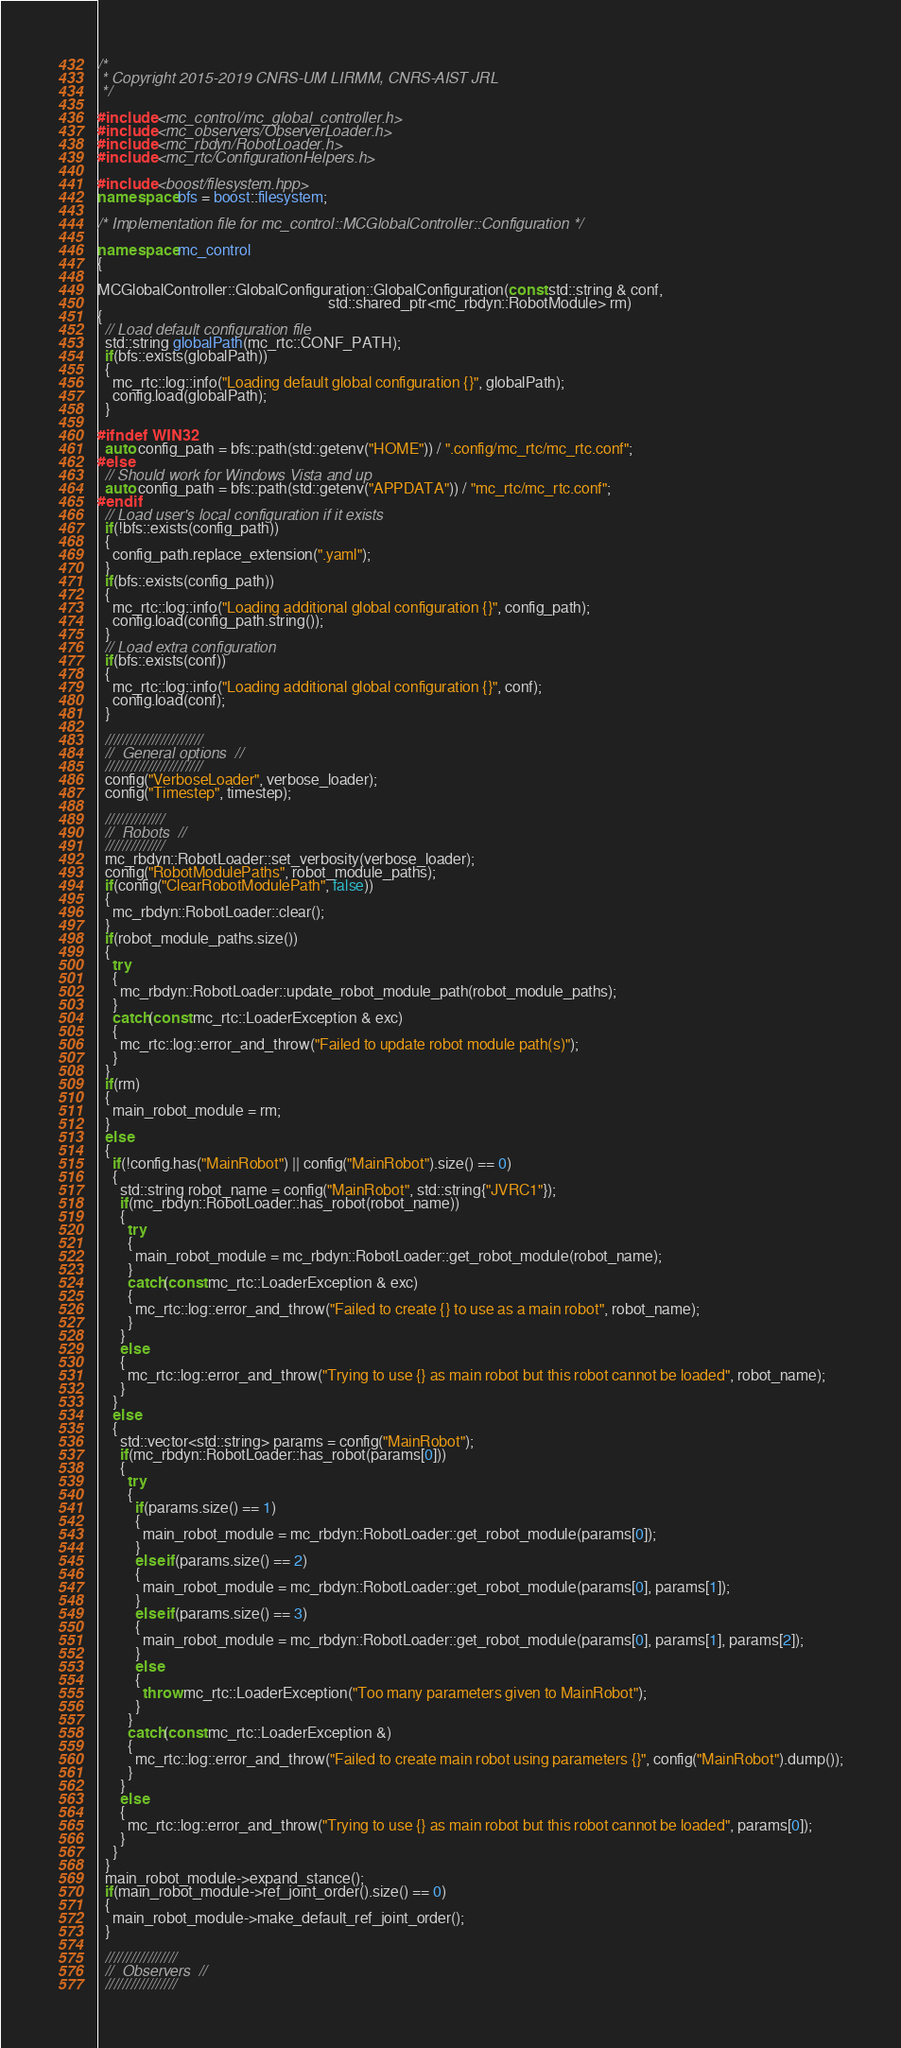Convert code to text. <code><loc_0><loc_0><loc_500><loc_500><_C++_>/*
 * Copyright 2015-2019 CNRS-UM LIRMM, CNRS-AIST JRL
 */

#include <mc_control/mc_global_controller.h>
#include <mc_observers/ObserverLoader.h>
#include <mc_rbdyn/RobotLoader.h>
#include <mc_rtc/ConfigurationHelpers.h>

#include <boost/filesystem.hpp>
namespace bfs = boost::filesystem;

/* Implementation file for mc_control::MCGlobalController::Configuration */

namespace mc_control
{

MCGlobalController::GlobalConfiguration::GlobalConfiguration(const std::string & conf,
                                                             std::shared_ptr<mc_rbdyn::RobotModule> rm)
{
  // Load default configuration file
  std::string globalPath(mc_rtc::CONF_PATH);
  if(bfs::exists(globalPath))
  {
    mc_rtc::log::info("Loading default global configuration {}", globalPath);
    config.load(globalPath);
  }

#ifndef WIN32
  auto config_path = bfs::path(std::getenv("HOME")) / ".config/mc_rtc/mc_rtc.conf";
#else
  // Should work for Windows Vista and up
  auto config_path = bfs::path(std::getenv("APPDATA")) / "mc_rtc/mc_rtc.conf";
#endif
  // Load user's local configuration if it exists
  if(!bfs::exists(config_path))
  {
    config_path.replace_extension(".yaml");
  }
  if(bfs::exists(config_path))
  {
    mc_rtc::log::info("Loading additional global configuration {}", config_path);
    config.load(config_path.string());
  }
  // Load extra configuration
  if(bfs::exists(conf))
  {
    mc_rtc::log::info("Loading additional global configuration {}", conf);
    config.load(conf);
  }

  ///////////////////////
  //  General options  //
  ///////////////////////
  config("VerboseLoader", verbose_loader);
  config("Timestep", timestep);

  //////////////
  //  Robots  //
  //////////////
  mc_rbdyn::RobotLoader::set_verbosity(verbose_loader);
  config("RobotModulePaths", robot_module_paths);
  if(config("ClearRobotModulePath", false))
  {
    mc_rbdyn::RobotLoader::clear();
  }
  if(robot_module_paths.size())
  {
    try
    {
      mc_rbdyn::RobotLoader::update_robot_module_path(robot_module_paths);
    }
    catch(const mc_rtc::LoaderException & exc)
    {
      mc_rtc::log::error_and_throw("Failed to update robot module path(s)");
    }
  }
  if(rm)
  {
    main_robot_module = rm;
  }
  else
  {
    if(!config.has("MainRobot") || config("MainRobot").size() == 0)
    {
      std::string robot_name = config("MainRobot", std::string{"JVRC1"});
      if(mc_rbdyn::RobotLoader::has_robot(robot_name))
      {
        try
        {
          main_robot_module = mc_rbdyn::RobotLoader::get_robot_module(robot_name);
        }
        catch(const mc_rtc::LoaderException & exc)
        {
          mc_rtc::log::error_and_throw("Failed to create {} to use as a main robot", robot_name);
        }
      }
      else
      {
        mc_rtc::log::error_and_throw("Trying to use {} as main robot but this robot cannot be loaded", robot_name);
      }
    }
    else
    {
      std::vector<std::string> params = config("MainRobot");
      if(mc_rbdyn::RobotLoader::has_robot(params[0]))
      {
        try
        {
          if(params.size() == 1)
          {
            main_robot_module = mc_rbdyn::RobotLoader::get_robot_module(params[0]);
          }
          else if(params.size() == 2)
          {
            main_robot_module = mc_rbdyn::RobotLoader::get_robot_module(params[0], params[1]);
          }
          else if(params.size() == 3)
          {
            main_robot_module = mc_rbdyn::RobotLoader::get_robot_module(params[0], params[1], params[2]);
          }
          else
          {
            throw mc_rtc::LoaderException("Too many parameters given to MainRobot");
          }
        }
        catch(const mc_rtc::LoaderException &)
        {
          mc_rtc::log::error_and_throw("Failed to create main robot using parameters {}", config("MainRobot").dump());
        }
      }
      else
      {
        mc_rtc::log::error_and_throw("Trying to use {} as main robot but this robot cannot be loaded", params[0]);
      }
    }
  }
  main_robot_module->expand_stance();
  if(main_robot_module->ref_joint_order().size() == 0)
  {
    main_robot_module->make_default_ref_joint_order();
  }

  /////////////////
  //  Observers  //
  /////////////////</code> 